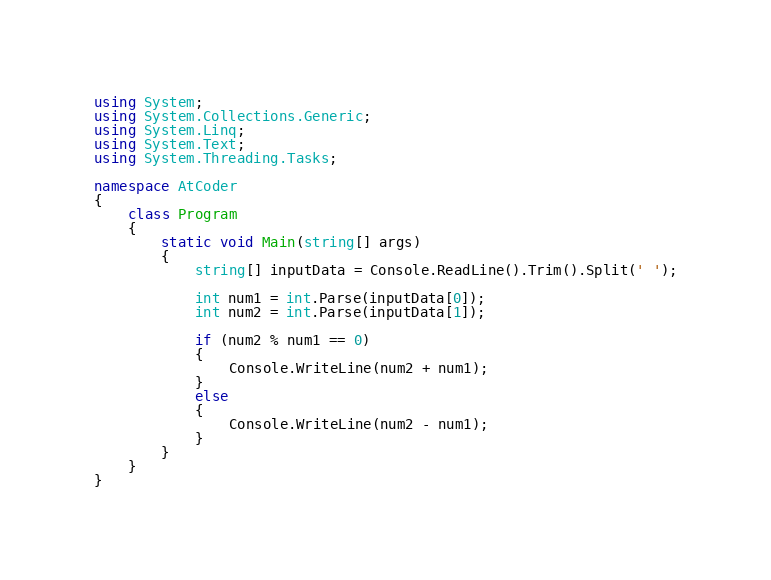Convert code to text. <code><loc_0><loc_0><loc_500><loc_500><_C#_>using System;
using System.Collections.Generic;
using System.Linq;
using System.Text;
using System.Threading.Tasks;

namespace AtCoder
{
    class Program
    {
        static void Main(string[] args)
        {
            string[] inputData = Console.ReadLine().Trim().Split(' ');

            int num1 = int.Parse(inputData[0]);
            int num2 = int.Parse(inputData[1]);

            if (num2 % num1 == 0)
            {
                Console.WriteLine(num2 + num1);
            }
            else
            {
                Console.WriteLine(num2 - num1);
            }
        }
    }
}
</code> 